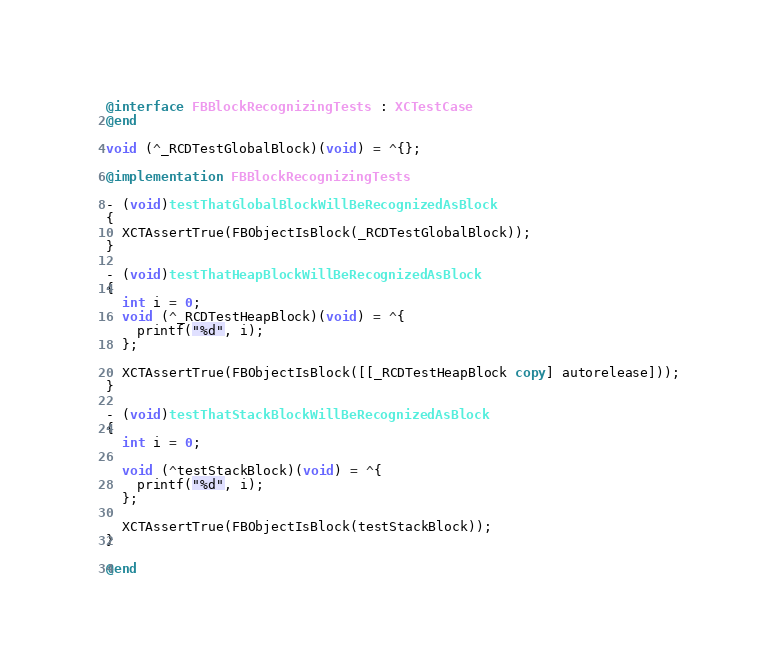Convert code to text. <code><loc_0><loc_0><loc_500><loc_500><_ObjectiveC_>
@interface FBBlockRecognizingTests : XCTestCase
@end

void (^_RCDTestGlobalBlock)(void) = ^{};

@implementation FBBlockRecognizingTests

- (void)testThatGlobalBlockWillBeRecognizedAsBlock
{
  XCTAssertTrue(FBObjectIsBlock(_RCDTestGlobalBlock));
}

- (void)testThatHeapBlockWillBeRecognizedAsBlock
{
  int i = 0;
  void (^_RCDTestHeapBlock)(void) = ^{
    printf("%d", i);
  };

  XCTAssertTrue(FBObjectIsBlock([[_RCDTestHeapBlock copy] autorelease]));
}

- (void)testThatStackBlockWillBeRecognizedAsBlock
{
  int i = 0;

  void (^testStackBlock)(void) = ^{
    printf("%d", i);
  };

  XCTAssertTrue(FBObjectIsBlock(testStackBlock));
}

@end
</code> 